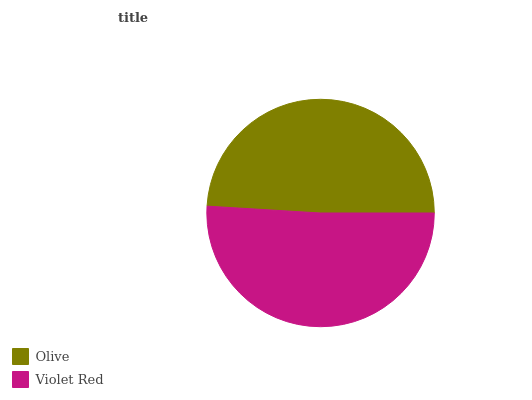Is Olive the minimum?
Answer yes or no. Yes. Is Violet Red the maximum?
Answer yes or no. Yes. Is Violet Red the minimum?
Answer yes or no. No. Is Violet Red greater than Olive?
Answer yes or no. Yes. Is Olive less than Violet Red?
Answer yes or no. Yes. Is Olive greater than Violet Red?
Answer yes or no. No. Is Violet Red less than Olive?
Answer yes or no. No. Is Violet Red the high median?
Answer yes or no. Yes. Is Olive the low median?
Answer yes or no. Yes. Is Olive the high median?
Answer yes or no. No. Is Violet Red the low median?
Answer yes or no. No. 